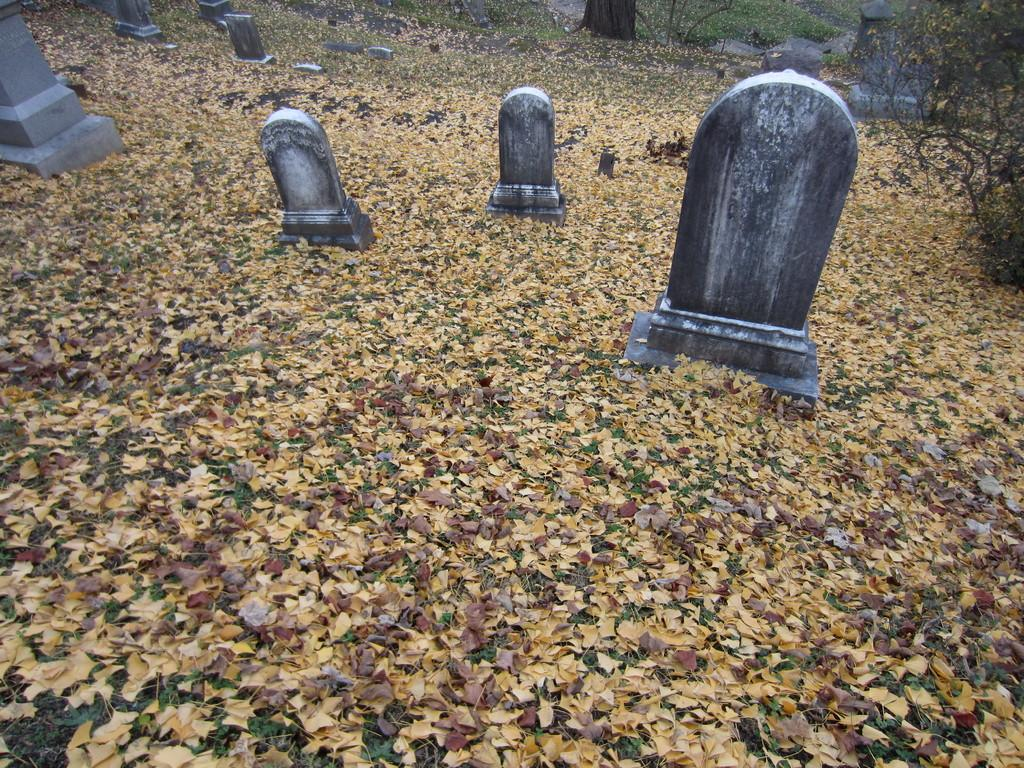What can be seen on the ground in the image? There are graves on the ground in the image. How would you describe the ground's appearance? The ground is covered with dry grass. What can be seen in the distance in the image? There are trees visible in the background of the image. What title is given to the force that can be heard in the image? There is no force or noise present in the image, so it is not possible to assign a title to it. 